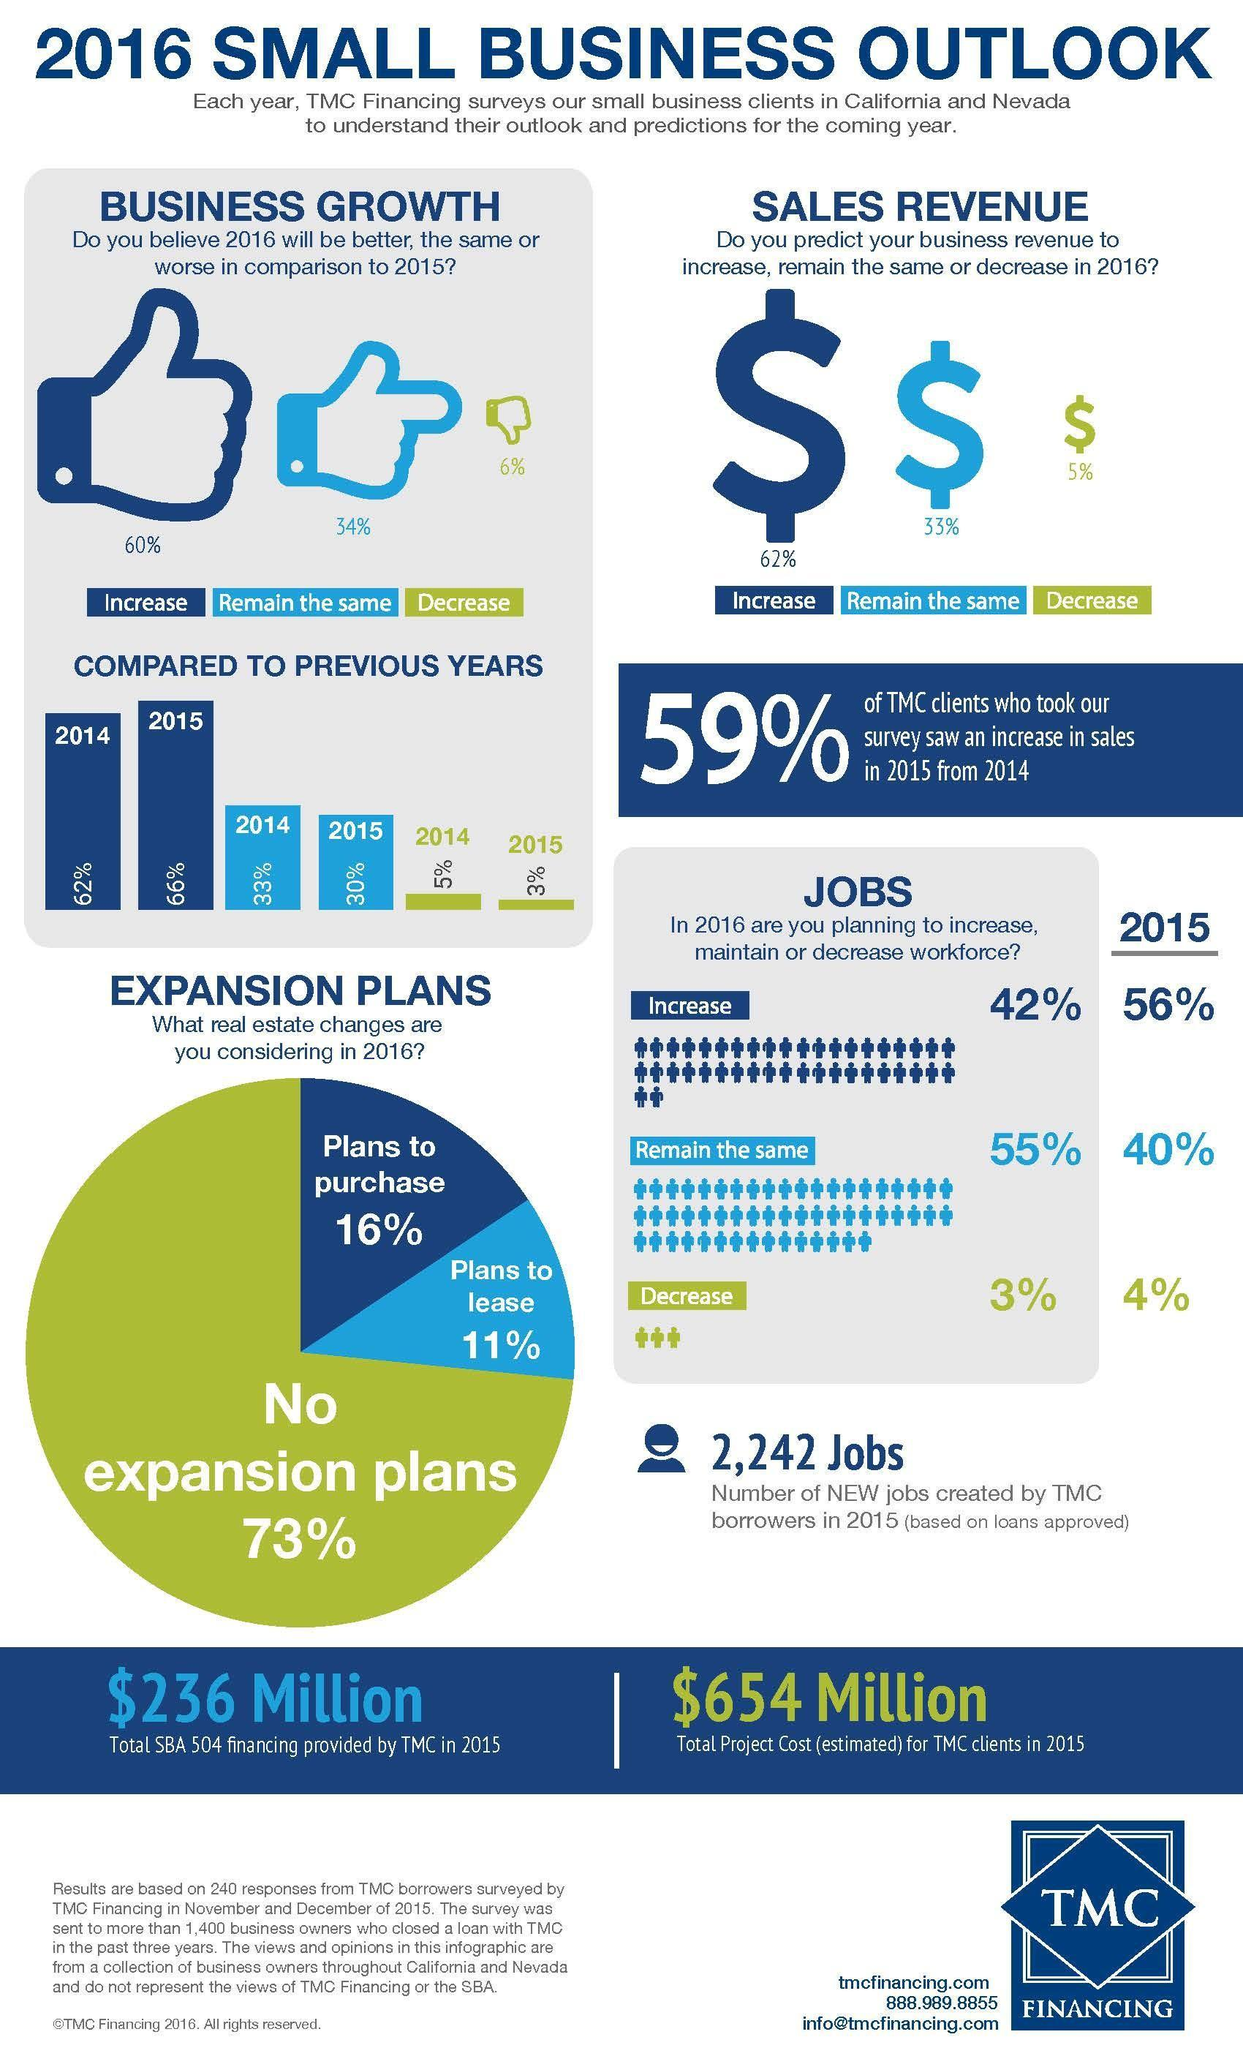What percent of TMC clients saw a decrease in sales in 2015 from 2014?
Answer the question with a short phrase. 41% What percent plans to both lease as well as purchase in 2016? 27% What percent think that business growth will be better in 2016? 60% 